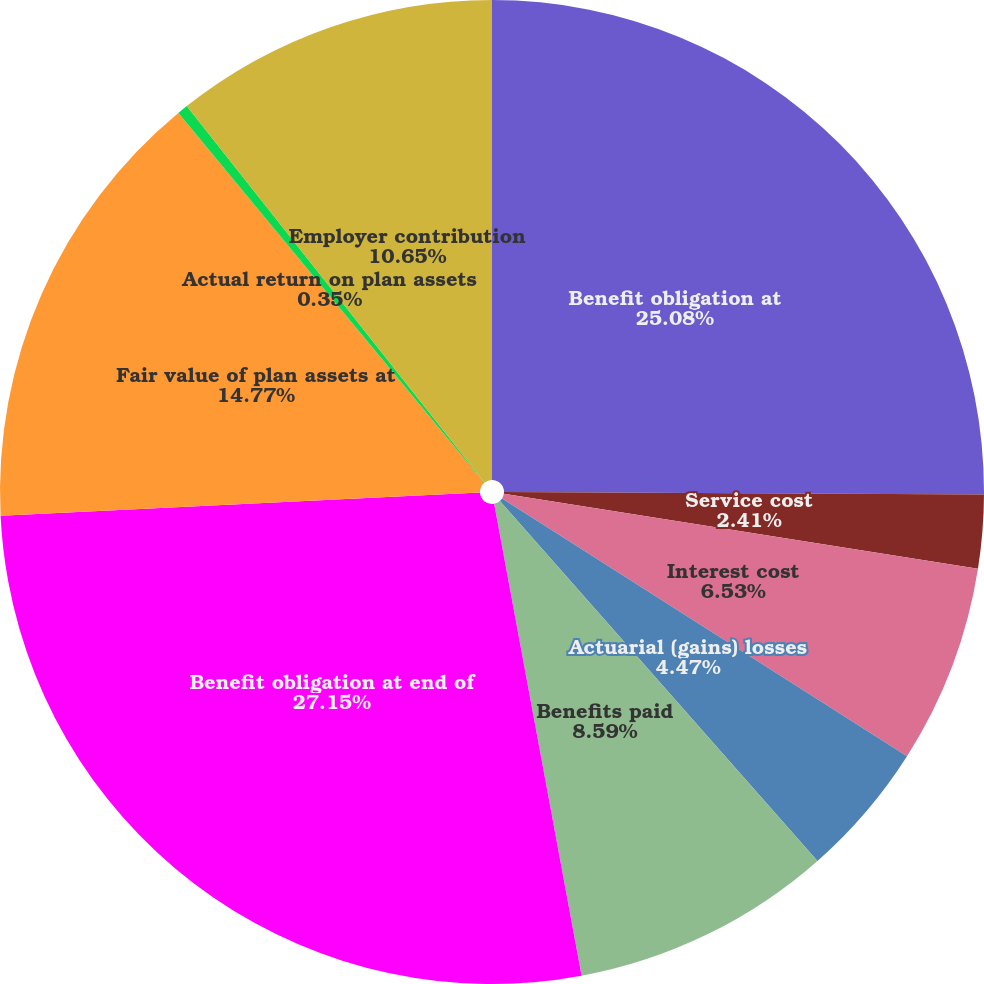Convert chart to OTSL. <chart><loc_0><loc_0><loc_500><loc_500><pie_chart><fcel>Benefit obligation at<fcel>Service cost<fcel>Interest cost<fcel>Actuarial (gains) losses<fcel>Benefits paid<fcel>Benefit obligation at end of<fcel>Fair value of plan assets at<fcel>Actual return on plan assets<fcel>Employer contribution<nl><fcel>25.08%<fcel>2.41%<fcel>6.53%<fcel>4.47%<fcel>8.59%<fcel>27.14%<fcel>14.77%<fcel>0.35%<fcel>10.65%<nl></chart> 